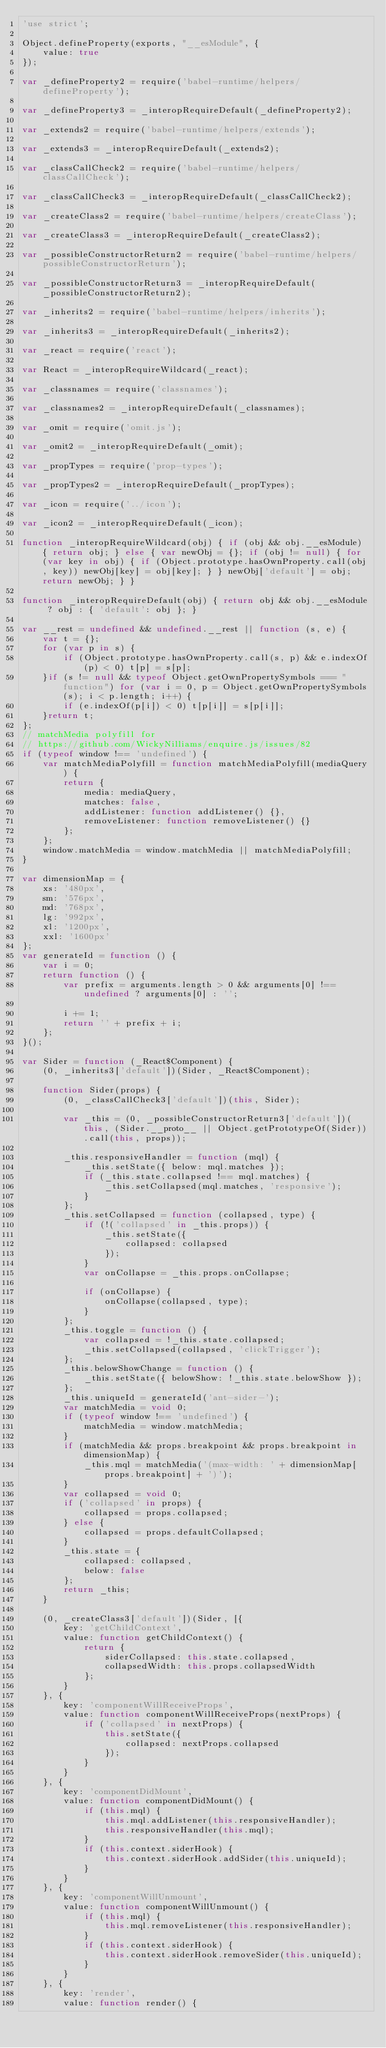<code> <loc_0><loc_0><loc_500><loc_500><_JavaScript_>'use strict';

Object.defineProperty(exports, "__esModule", {
    value: true
});

var _defineProperty2 = require('babel-runtime/helpers/defineProperty');

var _defineProperty3 = _interopRequireDefault(_defineProperty2);

var _extends2 = require('babel-runtime/helpers/extends');

var _extends3 = _interopRequireDefault(_extends2);

var _classCallCheck2 = require('babel-runtime/helpers/classCallCheck');

var _classCallCheck3 = _interopRequireDefault(_classCallCheck2);

var _createClass2 = require('babel-runtime/helpers/createClass');

var _createClass3 = _interopRequireDefault(_createClass2);

var _possibleConstructorReturn2 = require('babel-runtime/helpers/possibleConstructorReturn');

var _possibleConstructorReturn3 = _interopRequireDefault(_possibleConstructorReturn2);

var _inherits2 = require('babel-runtime/helpers/inherits');

var _inherits3 = _interopRequireDefault(_inherits2);

var _react = require('react');

var React = _interopRequireWildcard(_react);

var _classnames = require('classnames');

var _classnames2 = _interopRequireDefault(_classnames);

var _omit = require('omit.js');

var _omit2 = _interopRequireDefault(_omit);

var _propTypes = require('prop-types');

var _propTypes2 = _interopRequireDefault(_propTypes);

var _icon = require('../icon');

var _icon2 = _interopRequireDefault(_icon);

function _interopRequireWildcard(obj) { if (obj && obj.__esModule) { return obj; } else { var newObj = {}; if (obj != null) { for (var key in obj) { if (Object.prototype.hasOwnProperty.call(obj, key)) newObj[key] = obj[key]; } } newObj['default'] = obj; return newObj; } }

function _interopRequireDefault(obj) { return obj && obj.__esModule ? obj : { 'default': obj }; }

var __rest = undefined && undefined.__rest || function (s, e) {
    var t = {};
    for (var p in s) {
        if (Object.prototype.hasOwnProperty.call(s, p) && e.indexOf(p) < 0) t[p] = s[p];
    }if (s != null && typeof Object.getOwnPropertySymbols === "function") for (var i = 0, p = Object.getOwnPropertySymbols(s); i < p.length; i++) {
        if (e.indexOf(p[i]) < 0) t[p[i]] = s[p[i]];
    }return t;
};
// matchMedia polyfill for
// https://github.com/WickyNilliams/enquire.js/issues/82
if (typeof window !== 'undefined') {
    var matchMediaPolyfill = function matchMediaPolyfill(mediaQuery) {
        return {
            media: mediaQuery,
            matches: false,
            addListener: function addListener() {},
            removeListener: function removeListener() {}
        };
    };
    window.matchMedia = window.matchMedia || matchMediaPolyfill;
}

var dimensionMap = {
    xs: '480px',
    sm: '576px',
    md: '768px',
    lg: '992px',
    xl: '1200px',
    xxl: '1600px'
};
var generateId = function () {
    var i = 0;
    return function () {
        var prefix = arguments.length > 0 && arguments[0] !== undefined ? arguments[0] : '';

        i += 1;
        return '' + prefix + i;
    };
}();

var Sider = function (_React$Component) {
    (0, _inherits3['default'])(Sider, _React$Component);

    function Sider(props) {
        (0, _classCallCheck3['default'])(this, Sider);

        var _this = (0, _possibleConstructorReturn3['default'])(this, (Sider.__proto__ || Object.getPrototypeOf(Sider)).call(this, props));

        _this.responsiveHandler = function (mql) {
            _this.setState({ below: mql.matches });
            if (_this.state.collapsed !== mql.matches) {
                _this.setCollapsed(mql.matches, 'responsive');
            }
        };
        _this.setCollapsed = function (collapsed, type) {
            if (!('collapsed' in _this.props)) {
                _this.setState({
                    collapsed: collapsed
                });
            }
            var onCollapse = _this.props.onCollapse;

            if (onCollapse) {
                onCollapse(collapsed, type);
            }
        };
        _this.toggle = function () {
            var collapsed = !_this.state.collapsed;
            _this.setCollapsed(collapsed, 'clickTrigger');
        };
        _this.belowShowChange = function () {
            _this.setState({ belowShow: !_this.state.belowShow });
        };
        _this.uniqueId = generateId('ant-sider-');
        var matchMedia = void 0;
        if (typeof window !== 'undefined') {
            matchMedia = window.matchMedia;
        }
        if (matchMedia && props.breakpoint && props.breakpoint in dimensionMap) {
            _this.mql = matchMedia('(max-width: ' + dimensionMap[props.breakpoint] + ')');
        }
        var collapsed = void 0;
        if ('collapsed' in props) {
            collapsed = props.collapsed;
        } else {
            collapsed = props.defaultCollapsed;
        }
        _this.state = {
            collapsed: collapsed,
            below: false
        };
        return _this;
    }

    (0, _createClass3['default'])(Sider, [{
        key: 'getChildContext',
        value: function getChildContext() {
            return {
                siderCollapsed: this.state.collapsed,
                collapsedWidth: this.props.collapsedWidth
            };
        }
    }, {
        key: 'componentWillReceiveProps',
        value: function componentWillReceiveProps(nextProps) {
            if ('collapsed' in nextProps) {
                this.setState({
                    collapsed: nextProps.collapsed
                });
            }
        }
    }, {
        key: 'componentDidMount',
        value: function componentDidMount() {
            if (this.mql) {
                this.mql.addListener(this.responsiveHandler);
                this.responsiveHandler(this.mql);
            }
            if (this.context.siderHook) {
                this.context.siderHook.addSider(this.uniqueId);
            }
        }
    }, {
        key: 'componentWillUnmount',
        value: function componentWillUnmount() {
            if (this.mql) {
                this.mql.removeListener(this.responsiveHandler);
            }
            if (this.context.siderHook) {
                this.context.siderHook.removeSider(this.uniqueId);
            }
        }
    }, {
        key: 'render',
        value: function render() {</code> 